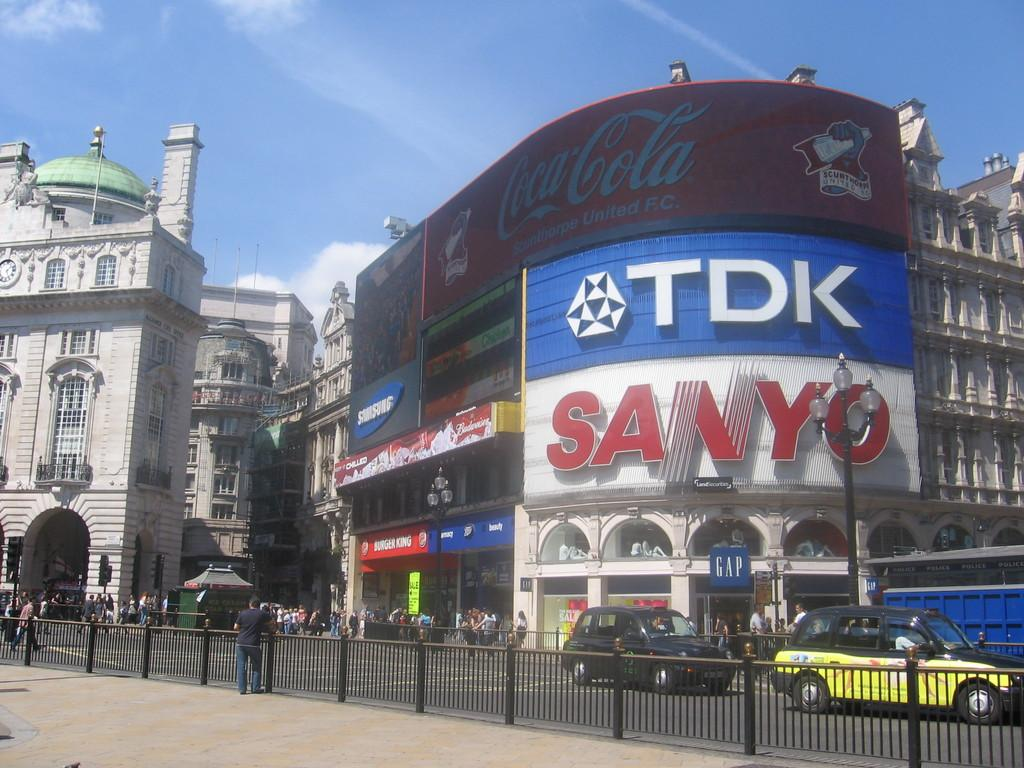<image>
Offer a succinct explanation of the picture presented. Across the street advertisements for Samsung, Budweiser, CocaCola, TDK, and Sanyo along with store fronts for Burger King and Gap 